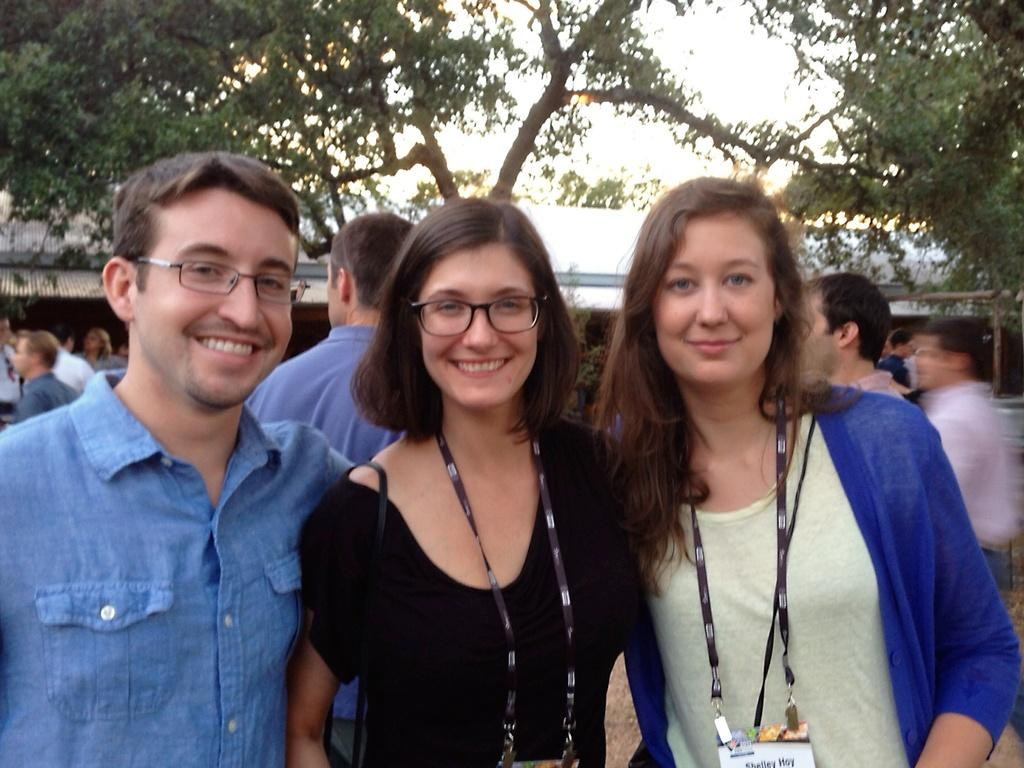How many people are smiling in the image? There are three people standing and smiling in the image. What can be seen in the background of the image? There is a group of people, a building, trees, and the sky visible in the background of the image. What might be the purpose of the group of people in the background? It is not clear from the image what the group of people in the background is doing or their purpose. What type of sign is being held by the person in the image? There is no sign visible in the image; the three people are simply standing and smiling. 